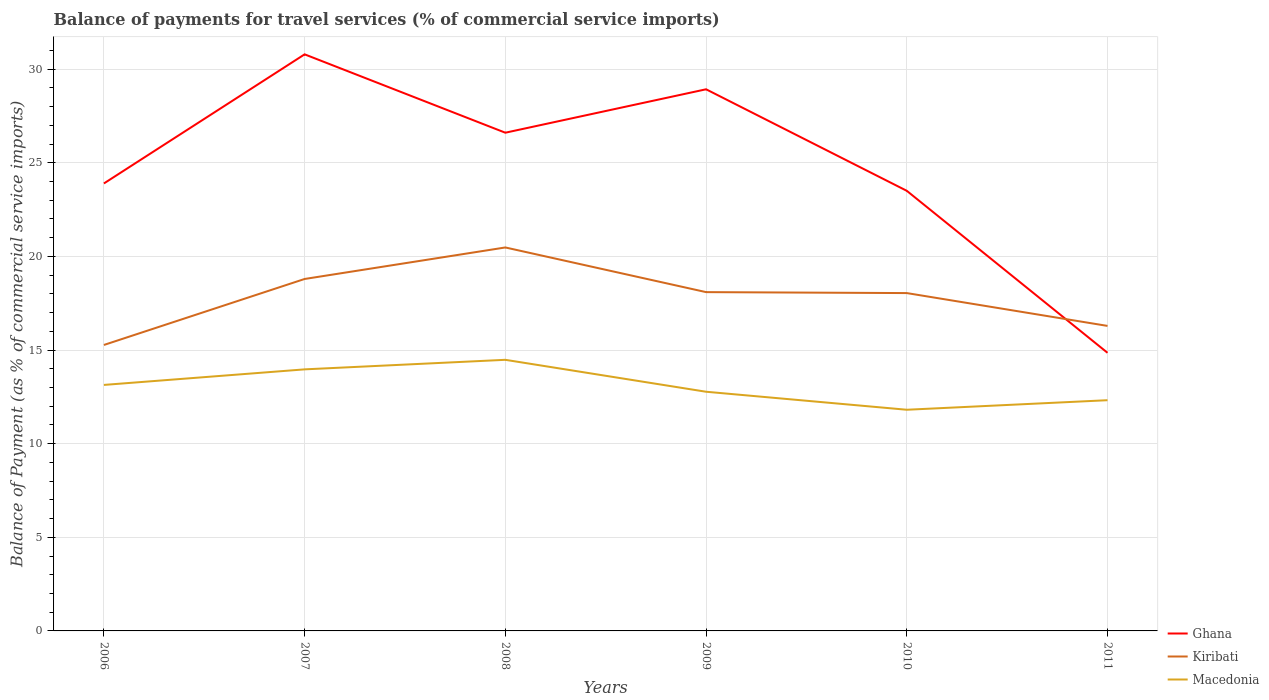Does the line corresponding to Ghana intersect with the line corresponding to Kiribati?
Give a very brief answer. Yes. Across all years, what is the maximum balance of payments for travel services in Kiribati?
Your answer should be compact. 15.27. What is the total balance of payments for travel services in Macedonia in the graph?
Your response must be concise. -1.34. What is the difference between the highest and the second highest balance of payments for travel services in Macedonia?
Make the answer very short. 2.67. What is the difference between the highest and the lowest balance of payments for travel services in Kiribati?
Ensure brevity in your answer.  4. Is the balance of payments for travel services in Kiribati strictly greater than the balance of payments for travel services in Ghana over the years?
Keep it short and to the point. No. How many lines are there?
Give a very brief answer. 3. What is the difference between two consecutive major ticks on the Y-axis?
Your response must be concise. 5. Are the values on the major ticks of Y-axis written in scientific E-notation?
Ensure brevity in your answer.  No. Does the graph contain grids?
Give a very brief answer. Yes. Where does the legend appear in the graph?
Give a very brief answer. Bottom right. What is the title of the graph?
Provide a short and direct response. Balance of payments for travel services (% of commercial service imports). Does "Least developed countries" appear as one of the legend labels in the graph?
Keep it short and to the point. No. What is the label or title of the X-axis?
Give a very brief answer. Years. What is the label or title of the Y-axis?
Offer a terse response. Balance of Payment (as % of commercial service imports). What is the Balance of Payment (as % of commercial service imports) in Ghana in 2006?
Offer a very short reply. 23.89. What is the Balance of Payment (as % of commercial service imports) of Kiribati in 2006?
Keep it short and to the point. 15.27. What is the Balance of Payment (as % of commercial service imports) of Macedonia in 2006?
Your answer should be very brief. 13.14. What is the Balance of Payment (as % of commercial service imports) in Ghana in 2007?
Keep it short and to the point. 30.79. What is the Balance of Payment (as % of commercial service imports) in Kiribati in 2007?
Offer a very short reply. 18.79. What is the Balance of Payment (as % of commercial service imports) in Macedonia in 2007?
Your response must be concise. 13.97. What is the Balance of Payment (as % of commercial service imports) of Ghana in 2008?
Ensure brevity in your answer.  26.6. What is the Balance of Payment (as % of commercial service imports) of Kiribati in 2008?
Provide a short and direct response. 20.48. What is the Balance of Payment (as % of commercial service imports) of Macedonia in 2008?
Keep it short and to the point. 14.48. What is the Balance of Payment (as % of commercial service imports) of Ghana in 2009?
Offer a terse response. 28.92. What is the Balance of Payment (as % of commercial service imports) of Kiribati in 2009?
Keep it short and to the point. 18.09. What is the Balance of Payment (as % of commercial service imports) of Macedonia in 2009?
Offer a terse response. 12.77. What is the Balance of Payment (as % of commercial service imports) in Ghana in 2010?
Offer a terse response. 23.5. What is the Balance of Payment (as % of commercial service imports) of Kiribati in 2010?
Provide a succinct answer. 18.04. What is the Balance of Payment (as % of commercial service imports) in Macedonia in 2010?
Your answer should be very brief. 11.81. What is the Balance of Payment (as % of commercial service imports) of Ghana in 2011?
Provide a short and direct response. 14.85. What is the Balance of Payment (as % of commercial service imports) of Kiribati in 2011?
Keep it short and to the point. 16.29. What is the Balance of Payment (as % of commercial service imports) of Macedonia in 2011?
Offer a very short reply. 12.32. Across all years, what is the maximum Balance of Payment (as % of commercial service imports) of Ghana?
Make the answer very short. 30.79. Across all years, what is the maximum Balance of Payment (as % of commercial service imports) in Kiribati?
Your response must be concise. 20.48. Across all years, what is the maximum Balance of Payment (as % of commercial service imports) of Macedonia?
Keep it short and to the point. 14.48. Across all years, what is the minimum Balance of Payment (as % of commercial service imports) of Ghana?
Make the answer very short. 14.85. Across all years, what is the minimum Balance of Payment (as % of commercial service imports) of Kiribati?
Make the answer very short. 15.27. Across all years, what is the minimum Balance of Payment (as % of commercial service imports) of Macedonia?
Your answer should be very brief. 11.81. What is the total Balance of Payment (as % of commercial service imports) in Ghana in the graph?
Provide a short and direct response. 148.56. What is the total Balance of Payment (as % of commercial service imports) of Kiribati in the graph?
Keep it short and to the point. 106.96. What is the total Balance of Payment (as % of commercial service imports) in Macedonia in the graph?
Your answer should be compact. 78.48. What is the difference between the Balance of Payment (as % of commercial service imports) of Ghana in 2006 and that in 2007?
Provide a succinct answer. -6.89. What is the difference between the Balance of Payment (as % of commercial service imports) in Kiribati in 2006 and that in 2007?
Ensure brevity in your answer.  -3.52. What is the difference between the Balance of Payment (as % of commercial service imports) in Macedonia in 2006 and that in 2007?
Ensure brevity in your answer.  -0.83. What is the difference between the Balance of Payment (as % of commercial service imports) of Ghana in 2006 and that in 2008?
Provide a short and direct response. -2.71. What is the difference between the Balance of Payment (as % of commercial service imports) in Kiribati in 2006 and that in 2008?
Keep it short and to the point. -5.21. What is the difference between the Balance of Payment (as % of commercial service imports) of Macedonia in 2006 and that in 2008?
Provide a succinct answer. -1.34. What is the difference between the Balance of Payment (as % of commercial service imports) of Ghana in 2006 and that in 2009?
Give a very brief answer. -5.03. What is the difference between the Balance of Payment (as % of commercial service imports) in Kiribati in 2006 and that in 2009?
Your answer should be compact. -2.82. What is the difference between the Balance of Payment (as % of commercial service imports) of Macedonia in 2006 and that in 2009?
Offer a very short reply. 0.36. What is the difference between the Balance of Payment (as % of commercial service imports) in Ghana in 2006 and that in 2010?
Your answer should be very brief. 0.39. What is the difference between the Balance of Payment (as % of commercial service imports) of Kiribati in 2006 and that in 2010?
Your response must be concise. -2.77. What is the difference between the Balance of Payment (as % of commercial service imports) in Macedonia in 2006 and that in 2010?
Give a very brief answer. 1.33. What is the difference between the Balance of Payment (as % of commercial service imports) in Ghana in 2006 and that in 2011?
Give a very brief answer. 9.04. What is the difference between the Balance of Payment (as % of commercial service imports) of Kiribati in 2006 and that in 2011?
Offer a very short reply. -1.02. What is the difference between the Balance of Payment (as % of commercial service imports) of Macedonia in 2006 and that in 2011?
Make the answer very short. 0.82. What is the difference between the Balance of Payment (as % of commercial service imports) of Ghana in 2007 and that in 2008?
Provide a short and direct response. 4.18. What is the difference between the Balance of Payment (as % of commercial service imports) of Kiribati in 2007 and that in 2008?
Your answer should be compact. -1.68. What is the difference between the Balance of Payment (as % of commercial service imports) of Macedonia in 2007 and that in 2008?
Give a very brief answer. -0.51. What is the difference between the Balance of Payment (as % of commercial service imports) of Ghana in 2007 and that in 2009?
Offer a very short reply. 1.87. What is the difference between the Balance of Payment (as % of commercial service imports) of Kiribati in 2007 and that in 2009?
Give a very brief answer. 0.7. What is the difference between the Balance of Payment (as % of commercial service imports) of Macedonia in 2007 and that in 2009?
Give a very brief answer. 1.19. What is the difference between the Balance of Payment (as % of commercial service imports) in Ghana in 2007 and that in 2010?
Your answer should be very brief. 7.29. What is the difference between the Balance of Payment (as % of commercial service imports) of Kiribati in 2007 and that in 2010?
Make the answer very short. 0.75. What is the difference between the Balance of Payment (as % of commercial service imports) in Macedonia in 2007 and that in 2010?
Offer a terse response. 2.16. What is the difference between the Balance of Payment (as % of commercial service imports) in Ghana in 2007 and that in 2011?
Provide a succinct answer. 15.94. What is the difference between the Balance of Payment (as % of commercial service imports) of Kiribati in 2007 and that in 2011?
Offer a very short reply. 2.51. What is the difference between the Balance of Payment (as % of commercial service imports) in Macedonia in 2007 and that in 2011?
Offer a very short reply. 1.65. What is the difference between the Balance of Payment (as % of commercial service imports) of Ghana in 2008 and that in 2009?
Your answer should be very brief. -2.32. What is the difference between the Balance of Payment (as % of commercial service imports) of Kiribati in 2008 and that in 2009?
Offer a terse response. 2.38. What is the difference between the Balance of Payment (as % of commercial service imports) of Macedonia in 2008 and that in 2009?
Make the answer very short. 1.7. What is the difference between the Balance of Payment (as % of commercial service imports) of Ghana in 2008 and that in 2010?
Give a very brief answer. 3.1. What is the difference between the Balance of Payment (as % of commercial service imports) of Kiribati in 2008 and that in 2010?
Your answer should be very brief. 2.44. What is the difference between the Balance of Payment (as % of commercial service imports) in Macedonia in 2008 and that in 2010?
Ensure brevity in your answer.  2.67. What is the difference between the Balance of Payment (as % of commercial service imports) of Ghana in 2008 and that in 2011?
Keep it short and to the point. 11.75. What is the difference between the Balance of Payment (as % of commercial service imports) in Kiribati in 2008 and that in 2011?
Your answer should be compact. 4.19. What is the difference between the Balance of Payment (as % of commercial service imports) in Macedonia in 2008 and that in 2011?
Ensure brevity in your answer.  2.16. What is the difference between the Balance of Payment (as % of commercial service imports) in Ghana in 2009 and that in 2010?
Keep it short and to the point. 5.42. What is the difference between the Balance of Payment (as % of commercial service imports) of Kiribati in 2009 and that in 2010?
Provide a short and direct response. 0.05. What is the difference between the Balance of Payment (as % of commercial service imports) of Macedonia in 2009 and that in 2010?
Offer a terse response. 0.96. What is the difference between the Balance of Payment (as % of commercial service imports) in Ghana in 2009 and that in 2011?
Ensure brevity in your answer.  14.07. What is the difference between the Balance of Payment (as % of commercial service imports) in Kiribati in 2009 and that in 2011?
Give a very brief answer. 1.8. What is the difference between the Balance of Payment (as % of commercial service imports) of Macedonia in 2009 and that in 2011?
Your answer should be compact. 0.45. What is the difference between the Balance of Payment (as % of commercial service imports) in Ghana in 2010 and that in 2011?
Your response must be concise. 8.65. What is the difference between the Balance of Payment (as % of commercial service imports) of Kiribati in 2010 and that in 2011?
Provide a short and direct response. 1.75. What is the difference between the Balance of Payment (as % of commercial service imports) in Macedonia in 2010 and that in 2011?
Your response must be concise. -0.51. What is the difference between the Balance of Payment (as % of commercial service imports) in Ghana in 2006 and the Balance of Payment (as % of commercial service imports) in Kiribati in 2007?
Offer a terse response. 5.1. What is the difference between the Balance of Payment (as % of commercial service imports) in Ghana in 2006 and the Balance of Payment (as % of commercial service imports) in Macedonia in 2007?
Keep it short and to the point. 9.93. What is the difference between the Balance of Payment (as % of commercial service imports) of Kiribati in 2006 and the Balance of Payment (as % of commercial service imports) of Macedonia in 2007?
Your answer should be very brief. 1.3. What is the difference between the Balance of Payment (as % of commercial service imports) of Ghana in 2006 and the Balance of Payment (as % of commercial service imports) of Kiribati in 2008?
Make the answer very short. 3.42. What is the difference between the Balance of Payment (as % of commercial service imports) of Ghana in 2006 and the Balance of Payment (as % of commercial service imports) of Macedonia in 2008?
Offer a terse response. 9.42. What is the difference between the Balance of Payment (as % of commercial service imports) of Kiribati in 2006 and the Balance of Payment (as % of commercial service imports) of Macedonia in 2008?
Make the answer very short. 0.79. What is the difference between the Balance of Payment (as % of commercial service imports) in Ghana in 2006 and the Balance of Payment (as % of commercial service imports) in Kiribati in 2009?
Provide a short and direct response. 5.8. What is the difference between the Balance of Payment (as % of commercial service imports) in Ghana in 2006 and the Balance of Payment (as % of commercial service imports) in Macedonia in 2009?
Make the answer very short. 11.12. What is the difference between the Balance of Payment (as % of commercial service imports) in Kiribati in 2006 and the Balance of Payment (as % of commercial service imports) in Macedonia in 2009?
Keep it short and to the point. 2.5. What is the difference between the Balance of Payment (as % of commercial service imports) of Ghana in 2006 and the Balance of Payment (as % of commercial service imports) of Kiribati in 2010?
Offer a very short reply. 5.85. What is the difference between the Balance of Payment (as % of commercial service imports) of Ghana in 2006 and the Balance of Payment (as % of commercial service imports) of Macedonia in 2010?
Keep it short and to the point. 12.08. What is the difference between the Balance of Payment (as % of commercial service imports) in Kiribati in 2006 and the Balance of Payment (as % of commercial service imports) in Macedonia in 2010?
Ensure brevity in your answer.  3.46. What is the difference between the Balance of Payment (as % of commercial service imports) of Ghana in 2006 and the Balance of Payment (as % of commercial service imports) of Kiribati in 2011?
Your answer should be compact. 7.61. What is the difference between the Balance of Payment (as % of commercial service imports) in Ghana in 2006 and the Balance of Payment (as % of commercial service imports) in Macedonia in 2011?
Provide a short and direct response. 11.57. What is the difference between the Balance of Payment (as % of commercial service imports) of Kiribati in 2006 and the Balance of Payment (as % of commercial service imports) of Macedonia in 2011?
Keep it short and to the point. 2.95. What is the difference between the Balance of Payment (as % of commercial service imports) of Ghana in 2007 and the Balance of Payment (as % of commercial service imports) of Kiribati in 2008?
Offer a very short reply. 10.31. What is the difference between the Balance of Payment (as % of commercial service imports) in Ghana in 2007 and the Balance of Payment (as % of commercial service imports) in Macedonia in 2008?
Keep it short and to the point. 16.31. What is the difference between the Balance of Payment (as % of commercial service imports) in Kiribati in 2007 and the Balance of Payment (as % of commercial service imports) in Macedonia in 2008?
Provide a short and direct response. 4.32. What is the difference between the Balance of Payment (as % of commercial service imports) in Ghana in 2007 and the Balance of Payment (as % of commercial service imports) in Kiribati in 2009?
Give a very brief answer. 12.7. What is the difference between the Balance of Payment (as % of commercial service imports) in Ghana in 2007 and the Balance of Payment (as % of commercial service imports) in Macedonia in 2009?
Ensure brevity in your answer.  18.02. What is the difference between the Balance of Payment (as % of commercial service imports) in Kiribati in 2007 and the Balance of Payment (as % of commercial service imports) in Macedonia in 2009?
Ensure brevity in your answer.  6.02. What is the difference between the Balance of Payment (as % of commercial service imports) in Ghana in 2007 and the Balance of Payment (as % of commercial service imports) in Kiribati in 2010?
Ensure brevity in your answer.  12.75. What is the difference between the Balance of Payment (as % of commercial service imports) in Ghana in 2007 and the Balance of Payment (as % of commercial service imports) in Macedonia in 2010?
Offer a very short reply. 18.98. What is the difference between the Balance of Payment (as % of commercial service imports) in Kiribati in 2007 and the Balance of Payment (as % of commercial service imports) in Macedonia in 2010?
Your response must be concise. 6.98. What is the difference between the Balance of Payment (as % of commercial service imports) in Ghana in 2007 and the Balance of Payment (as % of commercial service imports) in Kiribati in 2011?
Ensure brevity in your answer.  14.5. What is the difference between the Balance of Payment (as % of commercial service imports) of Ghana in 2007 and the Balance of Payment (as % of commercial service imports) of Macedonia in 2011?
Your answer should be compact. 18.47. What is the difference between the Balance of Payment (as % of commercial service imports) in Kiribati in 2007 and the Balance of Payment (as % of commercial service imports) in Macedonia in 2011?
Ensure brevity in your answer.  6.47. What is the difference between the Balance of Payment (as % of commercial service imports) in Ghana in 2008 and the Balance of Payment (as % of commercial service imports) in Kiribati in 2009?
Give a very brief answer. 8.51. What is the difference between the Balance of Payment (as % of commercial service imports) in Ghana in 2008 and the Balance of Payment (as % of commercial service imports) in Macedonia in 2009?
Give a very brief answer. 13.83. What is the difference between the Balance of Payment (as % of commercial service imports) of Kiribati in 2008 and the Balance of Payment (as % of commercial service imports) of Macedonia in 2009?
Provide a succinct answer. 7.7. What is the difference between the Balance of Payment (as % of commercial service imports) of Ghana in 2008 and the Balance of Payment (as % of commercial service imports) of Kiribati in 2010?
Ensure brevity in your answer.  8.56. What is the difference between the Balance of Payment (as % of commercial service imports) of Ghana in 2008 and the Balance of Payment (as % of commercial service imports) of Macedonia in 2010?
Provide a short and direct response. 14.79. What is the difference between the Balance of Payment (as % of commercial service imports) of Kiribati in 2008 and the Balance of Payment (as % of commercial service imports) of Macedonia in 2010?
Provide a short and direct response. 8.67. What is the difference between the Balance of Payment (as % of commercial service imports) of Ghana in 2008 and the Balance of Payment (as % of commercial service imports) of Kiribati in 2011?
Provide a short and direct response. 10.32. What is the difference between the Balance of Payment (as % of commercial service imports) in Ghana in 2008 and the Balance of Payment (as % of commercial service imports) in Macedonia in 2011?
Offer a terse response. 14.28. What is the difference between the Balance of Payment (as % of commercial service imports) in Kiribati in 2008 and the Balance of Payment (as % of commercial service imports) in Macedonia in 2011?
Ensure brevity in your answer.  8.16. What is the difference between the Balance of Payment (as % of commercial service imports) in Ghana in 2009 and the Balance of Payment (as % of commercial service imports) in Kiribati in 2010?
Give a very brief answer. 10.88. What is the difference between the Balance of Payment (as % of commercial service imports) of Ghana in 2009 and the Balance of Payment (as % of commercial service imports) of Macedonia in 2010?
Keep it short and to the point. 17.11. What is the difference between the Balance of Payment (as % of commercial service imports) in Kiribati in 2009 and the Balance of Payment (as % of commercial service imports) in Macedonia in 2010?
Offer a terse response. 6.28. What is the difference between the Balance of Payment (as % of commercial service imports) in Ghana in 2009 and the Balance of Payment (as % of commercial service imports) in Kiribati in 2011?
Keep it short and to the point. 12.64. What is the difference between the Balance of Payment (as % of commercial service imports) in Ghana in 2009 and the Balance of Payment (as % of commercial service imports) in Macedonia in 2011?
Provide a succinct answer. 16.6. What is the difference between the Balance of Payment (as % of commercial service imports) of Kiribati in 2009 and the Balance of Payment (as % of commercial service imports) of Macedonia in 2011?
Provide a short and direct response. 5.77. What is the difference between the Balance of Payment (as % of commercial service imports) in Ghana in 2010 and the Balance of Payment (as % of commercial service imports) in Kiribati in 2011?
Your answer should be compact. 7.21. What is the difference between the Balance of Payment (as % of commercial service imports) in Ghana in 2010 and the Balance of Payment (as % of commercial service imports) in Macedonia in 2011?
Your answer should be very brief. 11.18. What is the difference between the Balance of Payment (as % of commercial service imports) of Kiribati in 2010 and the Balance of Payment (as % of commercial service imports) of Macedonia in 2011?
Offer a very short reply. 5.72. What is the average Balance of Payment (as % of commercial service imports) of Ghana per year?
Make the answer very short. 24.76. What is the average Balance of Payment (as % of commercial service imports) of Kiribati per year?
Ensure brevity in your answer.  17.83. What is the average Balance of Payment (as % of commercial service imports) in Macedonia per year?
Offer a very short reply. 13.08. In the year 2006, what is the difference between the Balance of Payment (as % of commercial service imports) of Ghana and Balance of Payment (as % of commercial service imports) of Kiribati?
Ensure brevity in your answer.  8.63. In the year 2006, what is the difference between the Balance of Payment (as % of commercial service imports) in Ghana and Balance of Payment (as % of commercial service imports) in Macedonia?
Your answer should be very brief. 10.76. In the year 2006, what is the difference between the Balance of Payment (as % of commercial service imports) in Kiribati and Balance of Payment (as % of commercial service imports) in Macedonia?
Your answer should be very brief. 2.13. In the year 2007, what is the difference between the Balance of Payment (as % of commercial service imports) of Ghana and Balance of Payment (as % of commercial service imports) of Kiribati?
Provide a succinct answer. 12. In the year 2007, what is the difference between the Balance of Payment (as % of commercial service imports) of Ghana and Balance of Payment (as % of commercial service imports) of Macedonia?
Your answer should be very brief. 16.82. In the year 2007, what is the difference between the Balance of Payment (as % of commercial service imports) of Kiribati and Balance of Payment (as % of commercial service imports) of Macedonia?
Make the answer very short. 4.83. In the year 2008, what is the difference between the Balance of Payment (as % of commercial service imports) of Ghana and Balance of Payment (as % of commercial service imports) of Kiribati?
Make the answer very short. 6.13. In the year 2008, what is the difference between the Balance of Payment (as % of commercial service imports) in Ghana and Balance of Payment (as % of commercial service imports) in Macedonia?
Provide a succinct answer. 12.13. In the year 2008, what is the difference between the Balance of Payment (as % of commercial service imports) in Kiribati and Balance of Payment (as % of commercial service imports) in Macedonia?
Your response must be concise. 6. In the year 2009, what is the difference between the Balance of Payment (as % of commercial service imports) in Ghana and Balance of Payment (as % of commercial service imports) in Kiribati?
Your answer should be compact. 10.83. In the year 2009, what is the difference between the Balance of Payment (as % of commercial service imports) in Ghana and Balance of Payment (as % of commercial service imports) in Macedonia?
Provide a short and direct response. 16.15. In the year 2009, what is the difference between the Balance of Payment (as % of commercial service imports) in Kiribati and Balance of Payment (as % of commercial service imports) in Macedonia?
Provide a succinct answer. 5.32. In the year 2010, what is the difference between the Balance of Payment (as % of commercial service imports) of Ghana and Balance of Payment (as % of commercial service imports) of Kiribati?
Your answer should be very brief. 5.46. In the year 2010, what is the difference between the Balance of Payment (as % of commercial service imports) in Ghana and Balance of Payment (as % of commercial service imports) in Macedonia?
Provide a short and direct response. 11.69. In the year 2010, what is the difference between the Balance of Payment (as % of commercial service imports) of Kiribati and Balance of Payment (as % of commercial service imports) of Macedonia?
Provide a succinct answer. 6.23. In the year 2011, what is the difference between the Balance of Payment (as % of commercial service imports) of Ghana and Balance of Payment (as % of commercial service imports) of Kiribati?
Offer a very short reply. -1.44. In the year 2011, what is the difference between the Balance of Payment (as % of commercial service imports) of Ghana and Balance of Payment (as % of commercial service imports) of Macedonia?
Offer a terse response. 2.53. In the year 2011, what is the difference between the Balance of Payment (as % of commercial service imports) in Kiribati and Balance of Payment (as % of commercial service imports) in Macedonia?
Provide a succinct answer. 3.97. What is the ratio of the Balance of Payment (as % of commercial service imports) in Ghana in 2006 to that in 2007?
Your answer should be compact. 0.78. What is the ratio of the Balance of Payment (as % of commercial service imports) of Kiribati in 2006 to that in 2007?
Your answer should be compact. 0.81. What is the ratio of the Balance of Payment (as % of commercial service imports) of Macedonia in 2006 to that in 2007?
Ensure brevity in your answer.  0.94. What is the ratio of the Balance of Payment (as % of commercial service imports) in Ghana in 2006 to that in 2008?
Your answer should be very brief. 0.9. What is the ratio of the Balance of Payment (as % of commercial service imports) of Kiribati in 2006 to that in 2008?
Ensure brevity in your answer.  0.75. What is the ratio of the Balance of Payment (as % of commercial service imports) in Macedonia in 2006 to that in 2008?
Offer a terse response. 0.91. What is the ratio of the Balance of Payment (as % of commercial service imports) in Ghana in 2006 to that in 2009?
Provide a succinct answer. 0.83. What is the ratio of the Balance of Payment (as % of commercial service imports) of Kiribati in 2006 to that in 2009?
Your answer should be very brief. 0.84. What is the ratio of the Balance of Payment (as % of commercial service imports) of Macedonia in 2006 to that in 2009?
Ensure brevity in your answer.  1.03. What is the ratio of the Balance of Payment (as % of commercial service imports) of Ghana in 2006 to that in 2010?
Provide a succinct answer. 1.02. What is the ratio of the Balance of Payment (as % of commercial service imports) in Kiribati in 2006 to that in 2010?
Your answer should be very brief. 0.85. What is the ratio of the Balance of Payment (as % of commercial service imports) of Macedonia in 2006 to that in 2010?
Make the answer very short. 1.11. What is the ratio of the Balance of Payment (as % of commercial service imports) in Ghana in 2006 to that in 2011?
Offer a terse response. 1.61. What is the ratio of the Balance of Payment (as % of commercial service imports) in Macedonia in 2006 to that in 2011?
Your response must be concise. 1.07. What is the ratio of the Balance of Payment (as % of commercial service imports) of Ghana in 2007 to that in 2008?
Offer a terse response. 1.16. What is the ratio of the Balance of Payment (as % of commercial service imports) of Kiribati in 2007 to that in 2008?
Provide a succinct answer. 0.92. What is the ratio of the Balance of Payment (as % of commercial service imports) in Macedonia in 2007 to that in 2008?
Offer a terse response. 0.96. What is the ratio of the Balance of Payment (as % of commercial service imports) in Ghana in 2007 to that in 2009?
Keep it short and to the point. 1.06. What is the ratio of the Balance of Payment (as % of commercial service imports) in Kiribati in 2007 to that in 2009?
Your response must be concise. 1.04. What is the ratio of the Balance of Payment (as % of commercial service imports) in Macedonia in 2007 to that in 2009?
Offer a terse response. 1.09. What is the ratio of the Balance of Payment (as % of commercial service imports) of Ghana in 2007 to that in 2010?
Your response must be concise. 1.31. What is the ratio of the Balance of Payment (as % of commercial service imports) of Kiribati in 2007 to that in 2010?
Your answer should be very brief. 1.04. What is the ratio of the Balance of Payment (as % of commercial service imports) in Macedonia in 2007 to that in 2010?
Your answer should be very brief. 1.18. What is the ratio of the Balance of Payment (as % of commercial service imports) in Ghana in 2007 to that in 2011?
Your answer should be very brief. 2.07. What is the ratio of the Balance of Payment (as % of commercial service imports) in Kiribati in 2007 to that in 2011?
Ensure brevity in your answer.  1.15. What is the ratio of the Balance of Payment (as % of commercial service imports) in Macedonia in 2007 to that in 2011?
Offer a terse response. 1.13. What is the ratio of the Balance of Payment (as % of commercial service imports) of Ghana in 2008 to that in 2009?
Provide a short and direct response. 0.92. What is the ratio of the Balance of Payment (as % of commercial service imports) in Kiribati in 2008 to that in 2009?
Your answer should be compact. 1.13. What is the ratio of the Balance of Payment (as % of commercial service imports) of Macedonia in 2008 to that in 2009?
Offer a very short reply. 1.13. What is the ratio of the Balance of Payment (as % of commercial service imports) in Ghana in 2008 to that in 2010?
Ensure brevity in your answer.  1.13. What is the ratio of the Balance of Payment (as % of commercial service imports) in Kiribati in 2008 to that in 2010?
Provide a succinct answer. 1.14. What is the ratio of the Balance of Payment (as % of commercial service imports) in Macedonia in 2008 to that in 2010?
Keep it short and to the point. 1.23. What is the ratio of the Balance of Payment (as % of commercial service imports) in Ghana in 2008 to that in 2011?
Ensure brevity in your answer.  1.79. What is the ratio of the Balance of Payment (as % of commercial service imports) in Kiribati in 2008 to that in 2011?
Give a very brief answer. 1.26. What is the ratio of the Balance of Payment (as % of commercial service imports) of Macedonia in 2008 to that in 2011?
Provide a succinct answer. 1.18. What is the ratio of the Balance of Payment (as % of commercial service imports) in Ghana in 2009 to that in 2010?
Your answer should be compact. 1.23. What is the ratio of the Balance of Payment (as % of commercial service imports) in Macedonia in 2009 to that in 2010?
Your answer should be very brief. 1.08. What is the ratio of the Balance of Payment (as % of commercial service imports) of Ghana in 2009 to that in 2011?
Your answer should be very brief. 1.95. What is the ratio of the Balance of Payment (as % of commercial service imports) of Kiribati in 2009 to that in 2011?
Your response must be concise. 1.11. What is the ratio of the Balance of Payment (as % of commercial service imports) in Macedonia in 2009 to that in 2011?
Provide a succinct answer. 1.04. What is the ratio of the Balance of Payment (as % of commercial service imports) of Ghana in 2010 to that in 2011?
Provide a short and direct response. 1.58. What is the ratio of the Balance of Payment (as % of commercial service imports) in Kiribati in 2010 to that in 2011?
Your answer should be very brief. 1.11. What is the ratio of the Balance of Payment (as % of commercial service imports) of Macedonia in 2010 to that in 2011?
Your answer should be very brief. 0.96. What is the difference between the highest and the second highest Balance of Payment (as % of commercial service imports) in Ghana?
Give a very brief answer. 1.87. What is the difference between the highest and the second highest Balance of Payment (as % of commercial service imports) of Kiribati?
Make the answer very short. 1.68. What is the difference between the highest and the second highest Balance of Payment (as % of commercial service imports) of Macedonia?
Offer a terse response. 0.51. What is the difference between the highest and the lowest Balance of Payment (as % of commercial service imports) in Ghana?
Offer a terse response. 15.94. What is the difference between the highest and the lowest Balance of Payment (as % of commercial service imports) in Kiribati?
Provide a short and direct response. 5.21. What is the difference between the highest and the lowest Balance of Payment (as % of commercial service imports) in Macedonia?
Your answer should be compact. 2.67. 